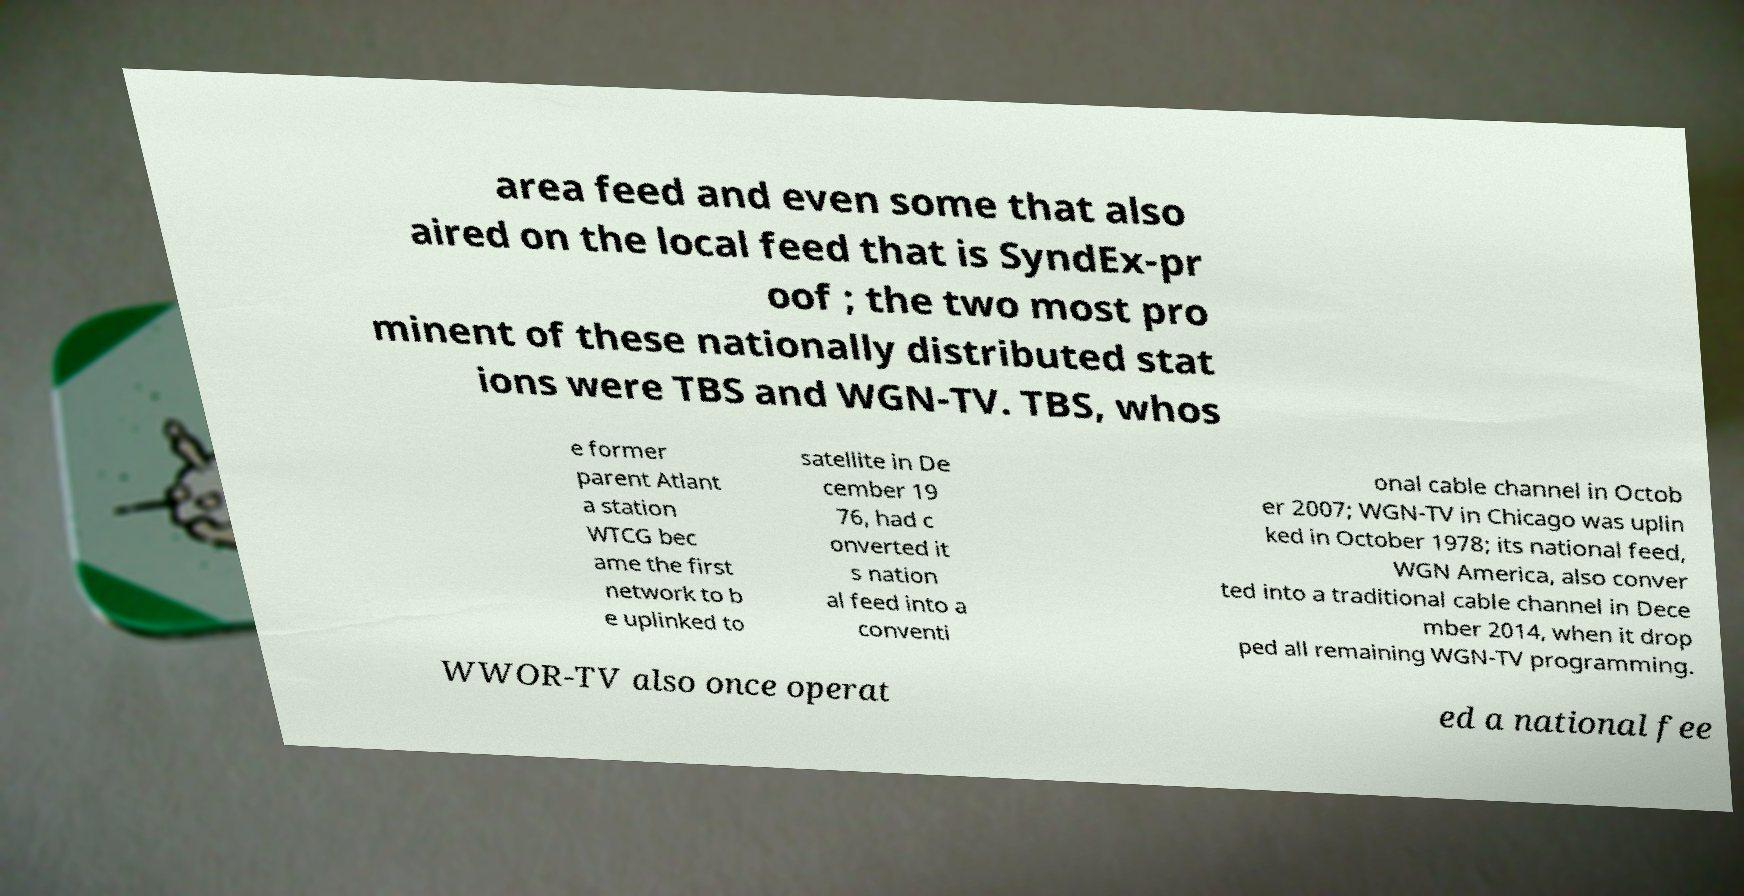Can you read and provide the text displayed in the image?This photo seems to have some interesting text. Can you extract and type it out for me? area feed and even some that also aired on the local feed that is SyndEx-pr oof ; the two most pro minent of these nationally distributed stat ions were TBS and WGN-TV. TBS, whos e former parent Atlant a station WTCG bec ame the first network to b e uplinked to satellite in De cember 19 76, had c onverted it s nation al feed into a conventi onal cable channel in Octob er 2007; WGN-TV in Chicago was uplin ked in October 1978; its national feed, WGN America, also conver ted into a traditional cable channel in Dece mber 2014, when it drop ped all remaining WGN-TV programming. WWOR-TV also once operat ed a national fee 